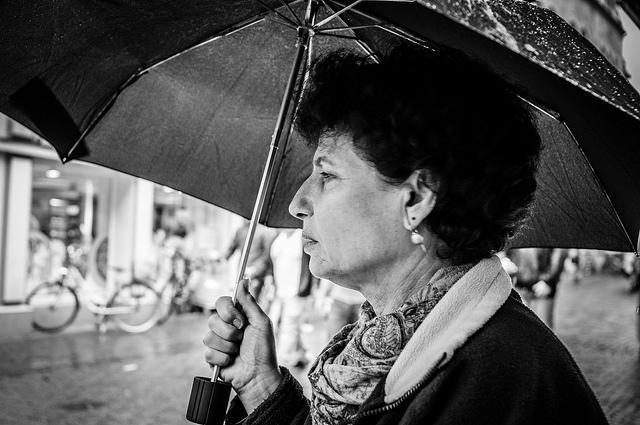How many people are there?
Give a very brief answer. 2. 